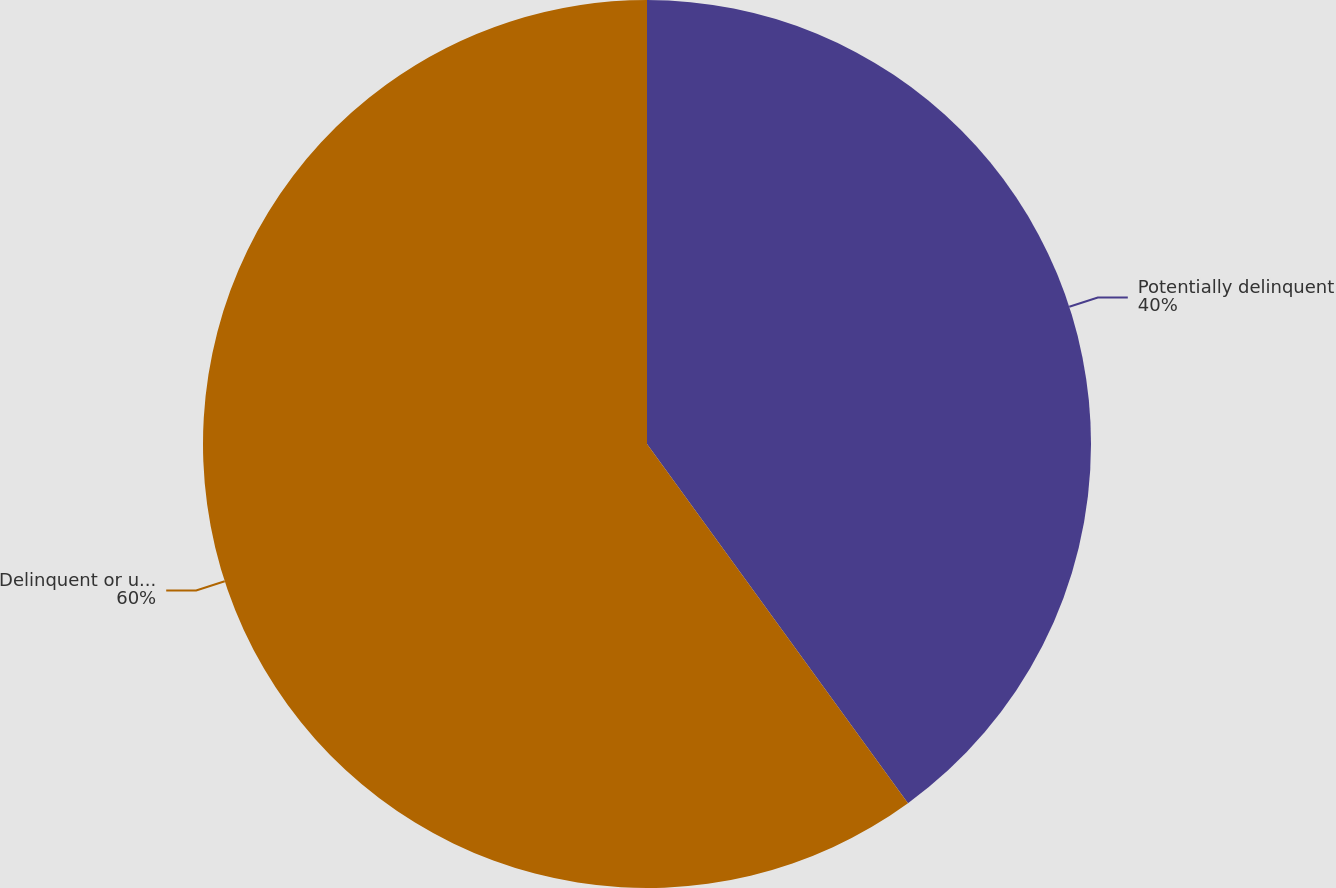<chart> <loc_0><loc_0><loc_500><loc_500><pie_chart><fcel>Potentially delinquent<fcel>Delinquent or under<nl><fcel>40.0%<fcel>60.0%<nl></chart> 